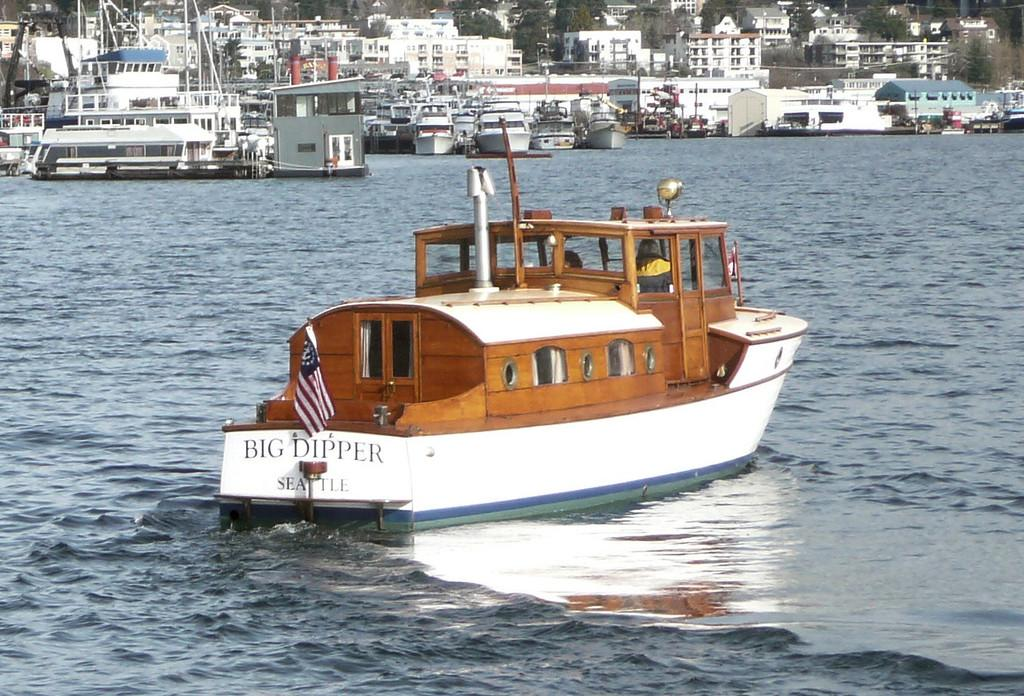What is the main subject of the image? The main subject of the image is a boat. What is the boat doing in the image? The boat is moving in the sea. How many boats can be seen in the image? There are many boats visible in the image. What can be seen in the background of the image? There are buildings in the background of the image. What type of camp can be seen in the image? There is no camp present in the image; it features a boat moving in the sea with other boats and buildings in the background. 